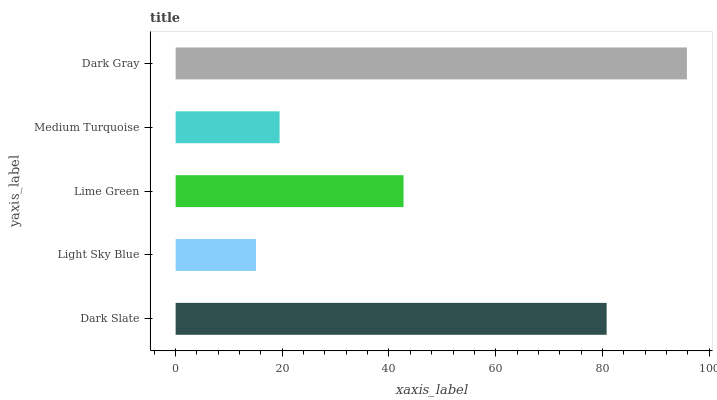Is Light Sky Blue the minimum?
Answer yes or no. Yes. Is Dark Gray the maximum?
Answer yes or no. Yes. Is Lime Green the minimum?
Answer yes or no. No. Is Lime Green the maximum?
Answer yes or no. No. Is Lime Green greater than Light Sky Blue?
Answer yes or no. Yes. Is Light Sky Blue less than Lime Green?
Answer yes or no. Yes. Is Light Sky Blue greater than Lime Green?
Answer yes or no. No. Is Lime Green less than Light Sky Blue?
Answer yes or no. No. Is Lime Green the high median?
Answer yes or no. Yes. Is Lime Green the low median?
Answer yes or no. Yes. Is Medium Turquoise the high median?
Answer yes or no. No. Is Dark Gray the low median?
Answer yes or no. No. 